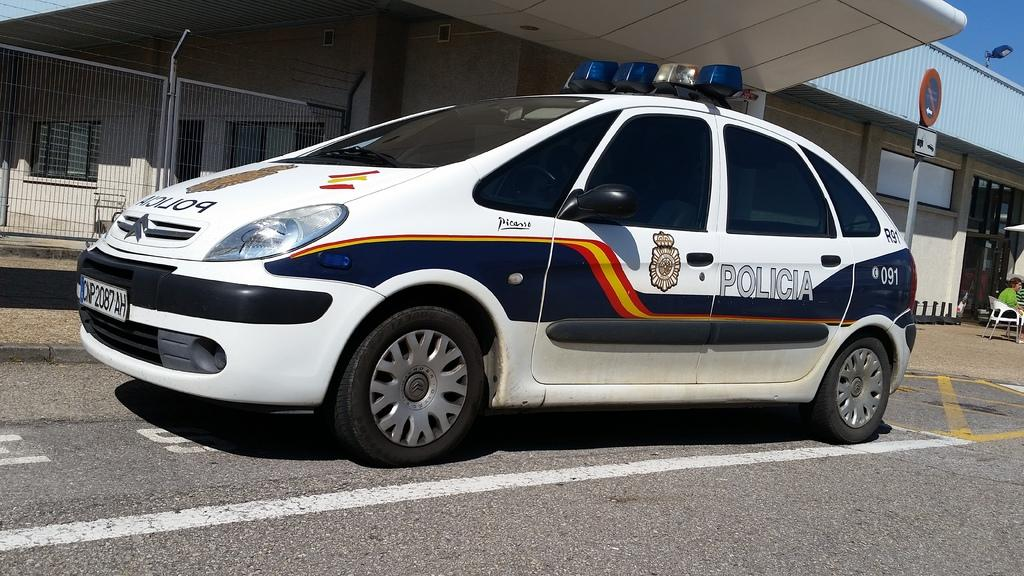What is the main subject in the center of the image? There is a car in the center of the image. Where is the car located? The car is on the road. What can be seen in the background of the image? There is sky, at least one building, a wall, a sign board, a fence, windows, and a person sitting on a chair visible in the background of the image. What type of feather can be seen floating near the car in the image? There is no feather present in the image; it only features a car on the road and various elements in the background. 